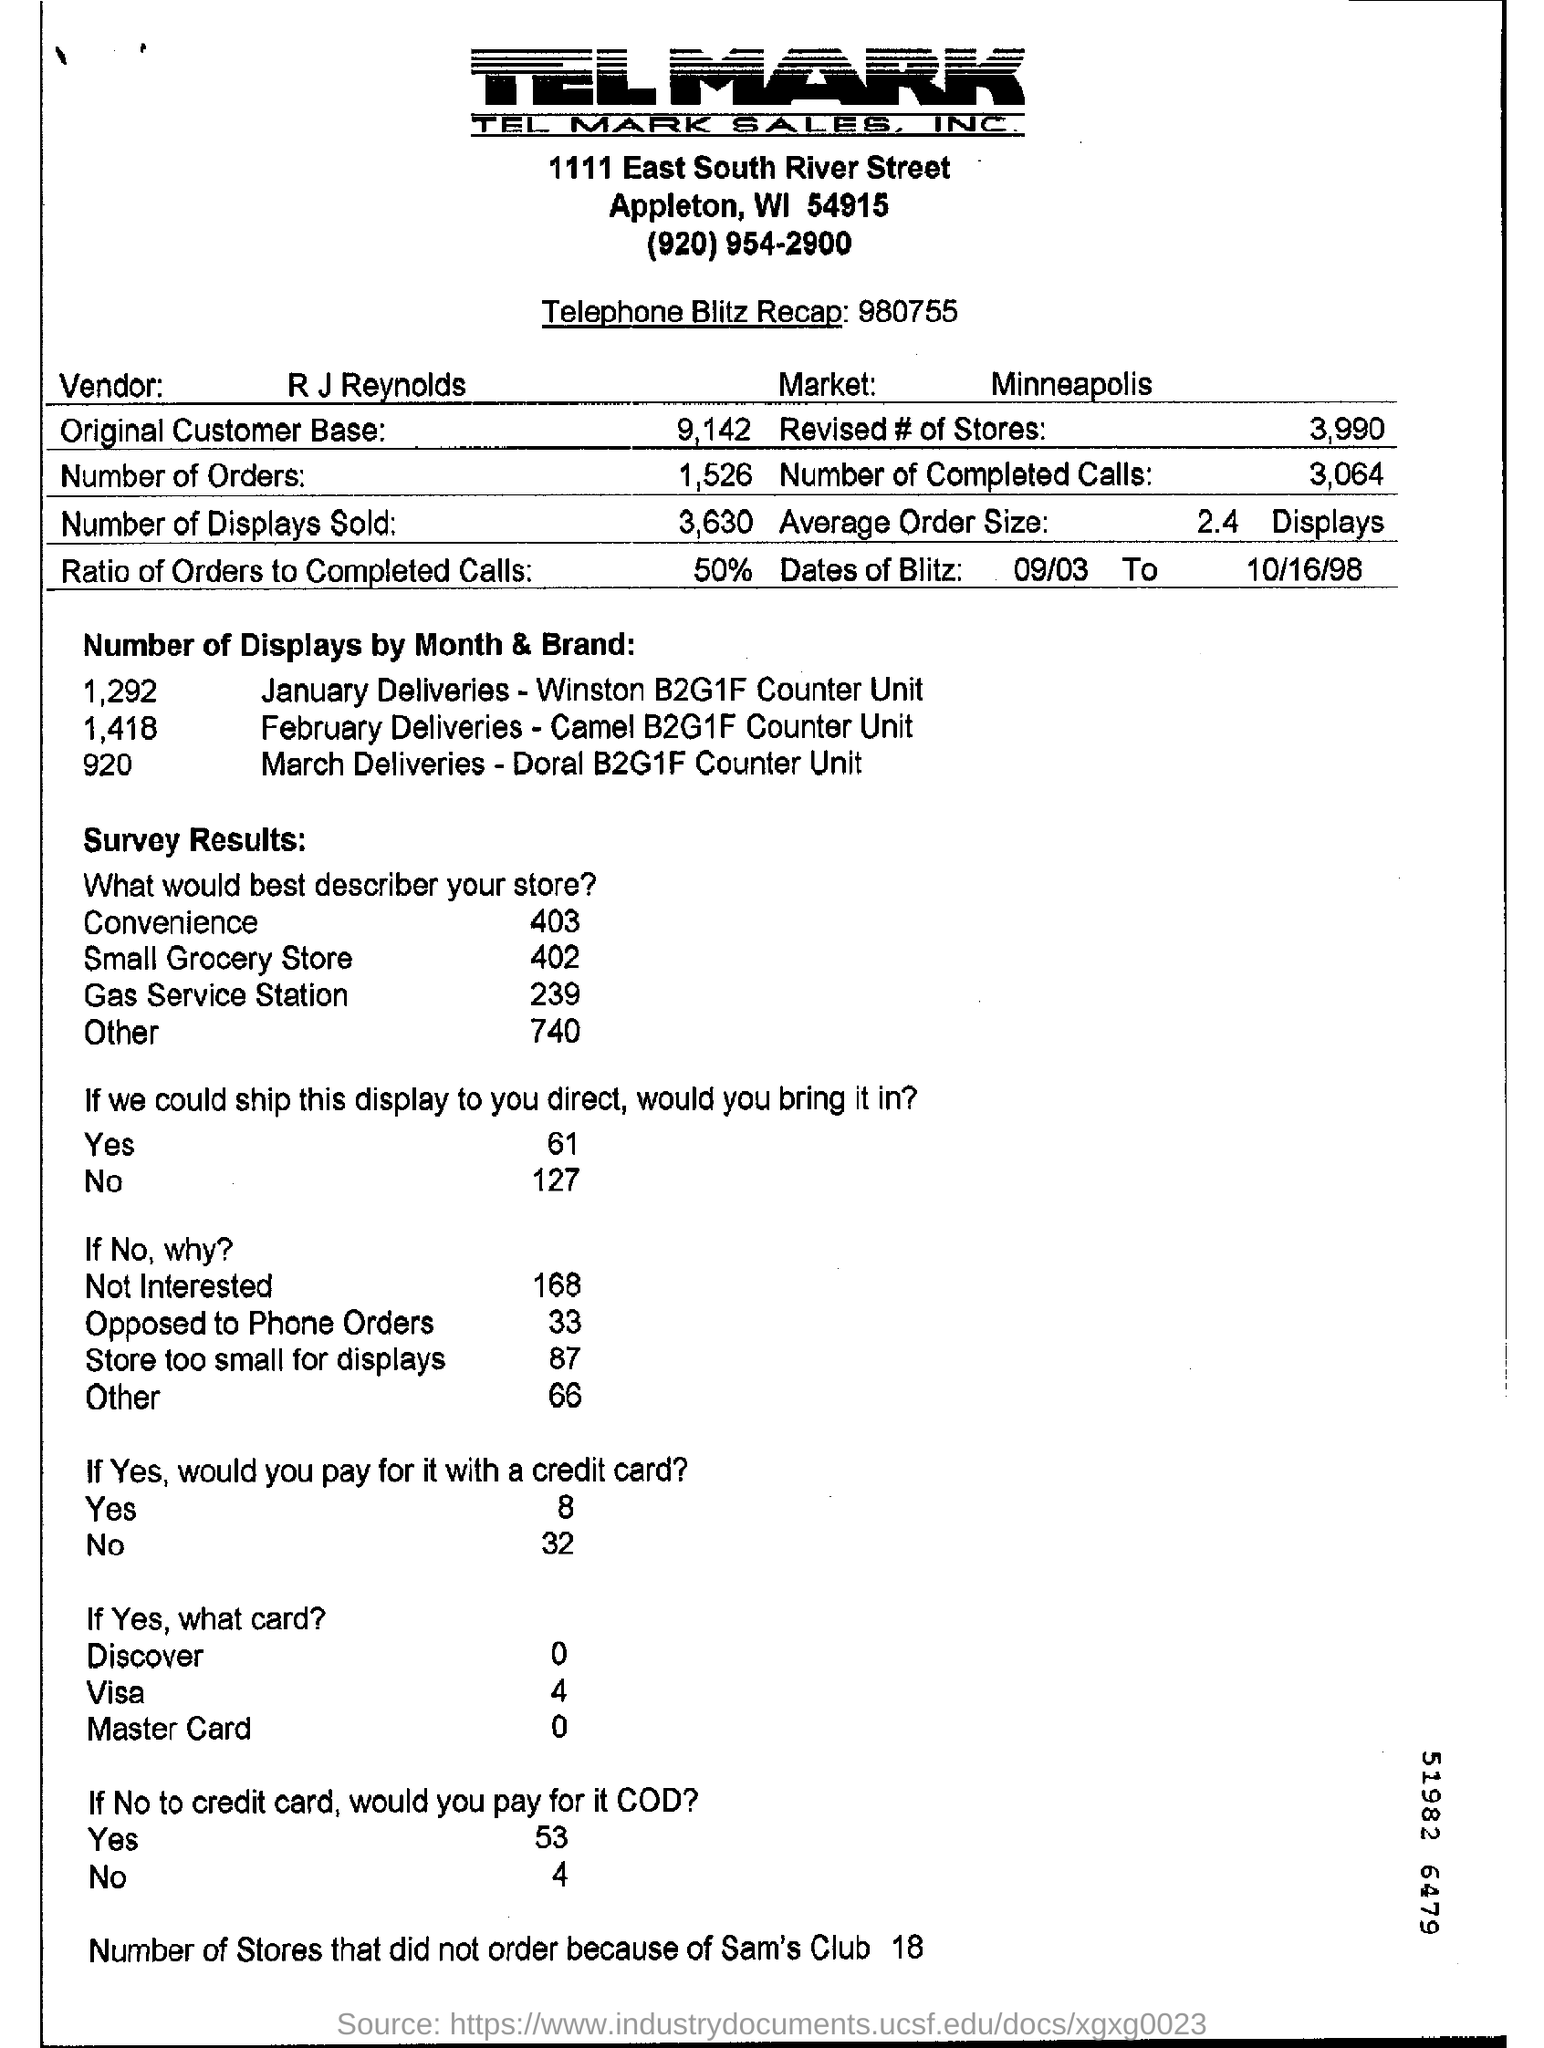What is the name of the vendor?
Ensure brevity in your answer.  R J Reynolds. How many number of orders?
Make the answer very short. 1,526. 